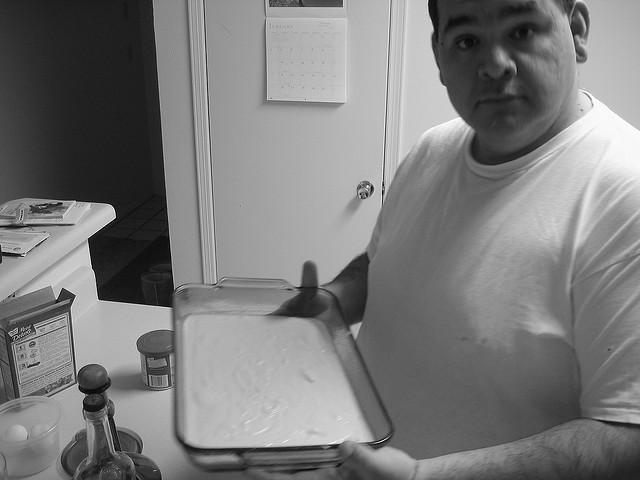How many plates?
Give a very brief answer. 0. How many bottles can you see?
Give a very brief answer. 2. How many people can be seen?
Give a very brief answer. 1. 